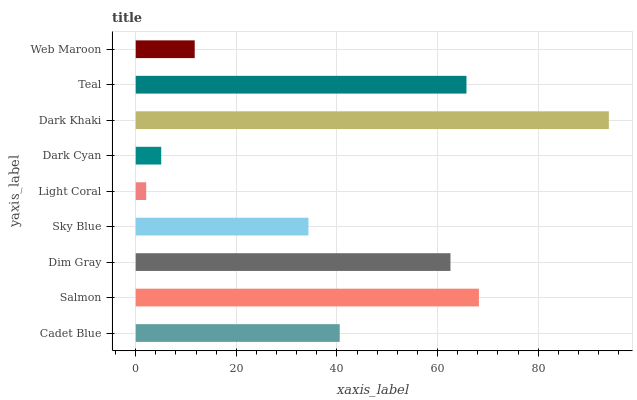Is Light Coral the minimum?
Answer yes or no. Yes. Is Dark Khaki the maximum?
Answer yes or no. Yes. Is Salmon the minimum?
Answer yes or no. No. Is Salmon the maximum?
Answer yes or no. No. Is Salmon greater than Cadet Blue?
Answer yes or no. Yes. Is Cadet Blue less than Salmon?
Answer yes or no. Yes. Is Cadet Blue greater than Salmon?
Answer yes or no. No. Is Salmon less than Cadet Blue?
Answer yes or no. No. Is Cadet Blue the high median?
Answer yes or no. Yes. Is Cadet Blue the low median?
Answer yes or no. Yes. Is Sky Blue the high median?
Answer yes or no. No. Is Web Maroon the low median?
Answer yes or no. No. 